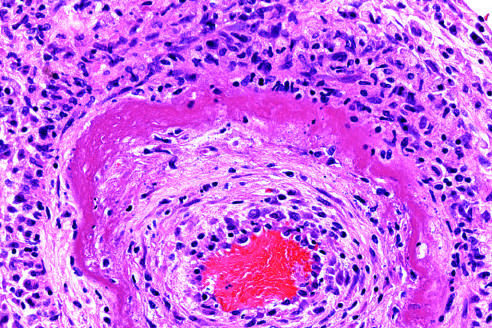does the wall of the artery show a circumferential bright pink area of necrosis with protein deposition and inflammation?
Answer the question using a single word or phrase. Yes 